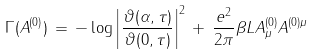Convert formula to latex. <formula><loc_0><loc_0><loc_500><loc_500>\Gamma ( A ^ { ( 0 ) } ) \, = \, - \log \left | \frac { \vartheta ( \alpha , \tau ) } { \vartheta ( 0 , \tau ) } \right | ^ { 2 } \, + \, \frac { e ^ { 2 } } { 2 \pi } \beta L { A } ^ { ( 0 ) } _ { \mu } { A } ^ { ( 0 ) \mu }</formula> 